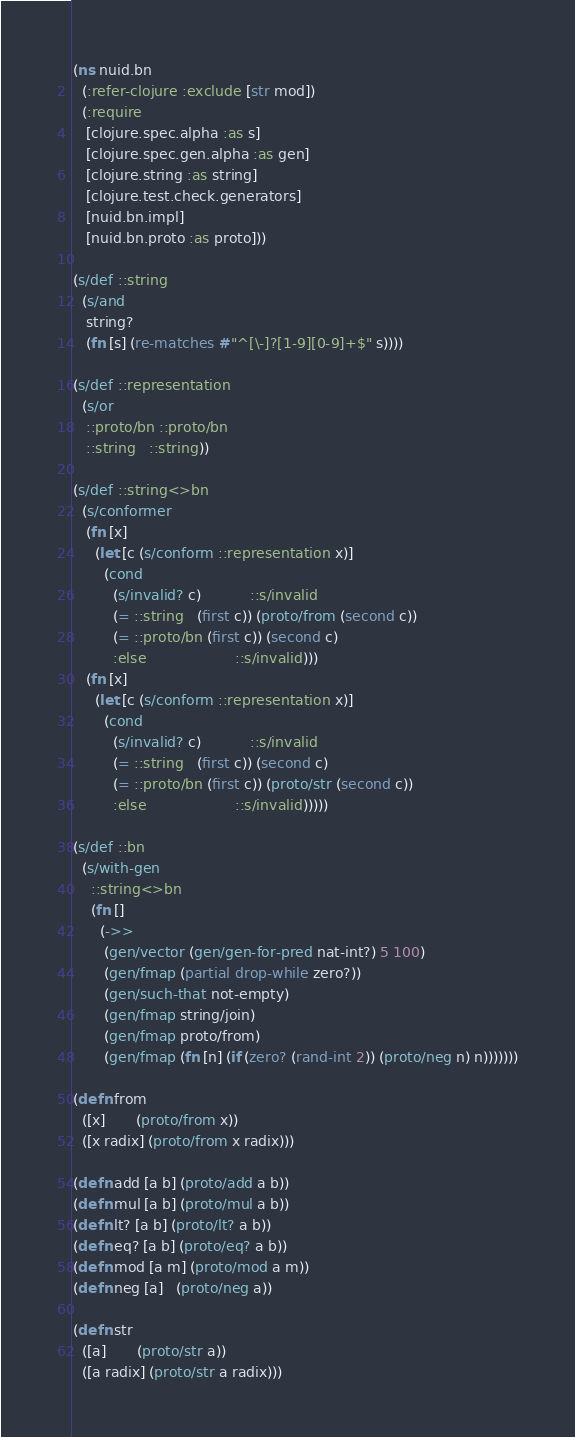<code> <loc_0><loc_0><loc_500><loc_500><_Clojure_>(ns nuid.bn
  (:refer-clojure :exclude [str mod])
  (:require
   [clojure.spec.alpha :as s]
   [clojure.spec.gen.alpha :as gen]
   [clojure.string :as string]
   [clojure.test.check.generators]
   [nuid.bn.impl]
   [nuid.bn.proto :as proto]))

(s/def ::string
  (s/and
   string?
   (fn [s] (re-matches #"^[\-]?[1-9][0-9]+$" s))))

(s/def ::representation
  (s/or
   ::proto/bn ::proto/bn
   ::string   ::string))

(s/def ::string<>bn
  (s/conformer
   (fn [x]
     (let [c (s/conform ::representation x)]
       (cond
         (s/invalid? c)           ::s/invalid
         (= ::string   (first c)) (proto/from (second c))
         (= ::proto/bn (first c)) (second c)
         :else                    ::s/invalid)))
   (fn [x]
     (let [c (s/conform ::representation x)]
       (cond
         (s/invalid? c)           ::s/invalid
         (= ::string   (first c)) (second c)
         (= ::proto/bn (first c)) (proto/str (second c))
         :else                    ::s/invalid)))))

(s/def ::bn
  (s/with-gen
    ::string<>bn
    (fn []
      (->>
       (gen/vector (gen/gen-for-pred nat-int?) 5 100)
       (gen/fmap (partial drop-while zero?))
       (gen/such-that not-empty)
       (gen/fmap string/join)
       (gen/fmap proto/from)
       (gen/fmap (fn [n] (if (zero? (rand-int 2)) (proto/neg n) n)))))))

(defn from
  ([x]       (proto/from x))
  ([x radix] (proto/from x radix)))

(defn add [a b] (proto/add a b))
(defn mul [a b] (proto/mul a b))
(defn lt? [a b] (proto/lt? a b))
(defn eq? [a b] (proto/eq? a b))
(defn mod [a m] (proto/mod a m))
(defn neg [a]   (proto/neg a))

(defn str
  ([a]       (proto/str a))
  ([a radix] (proto/str a radix)))
</code> 